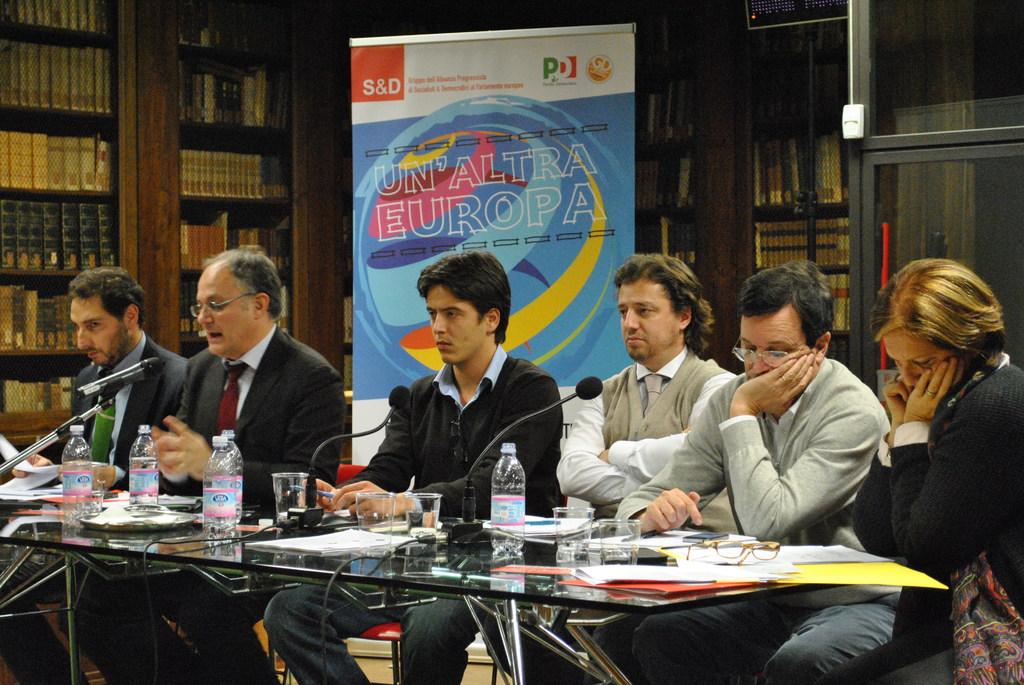Where is being held?
Ensure brevity in your answer.  Europa. What number and letter combo is in the orange box?
Your answer should be compact. S&d. 